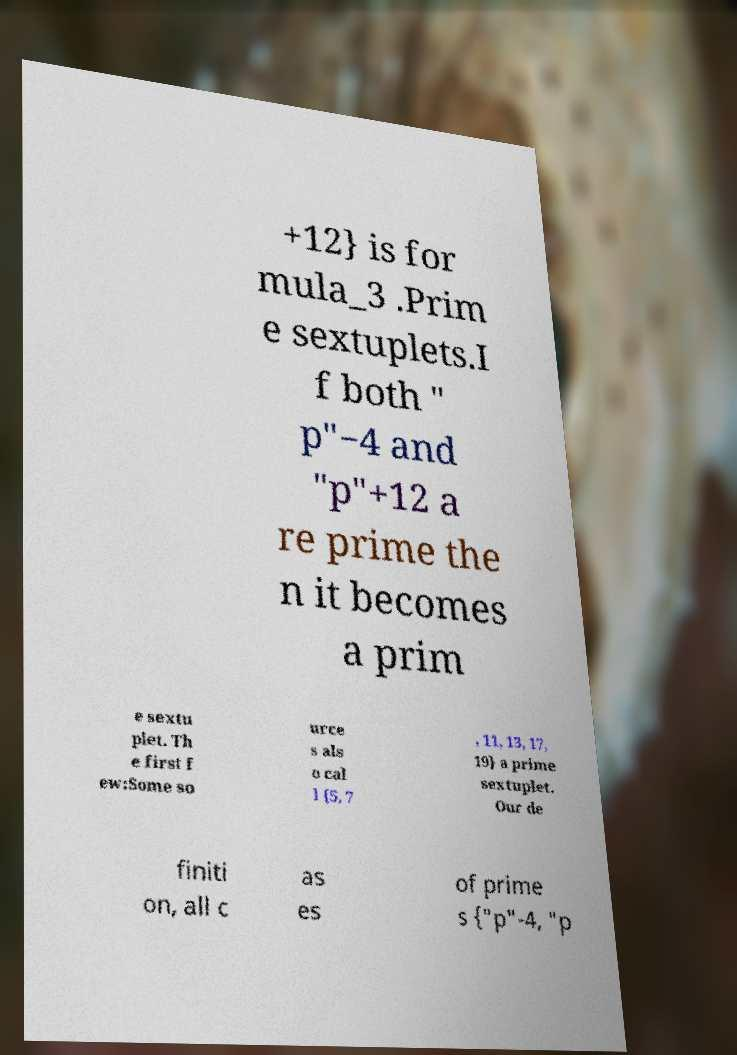Could you extract and type out the text from this image? +12} is for mula_3 .Prim e sextuplets.I f both " p"−4 and "p"+12 a re prime the n it becomes a prim e sextu plet. Th e first f ew:Some so urce s als o cal l {5, 7 , 11, 13, 17, 19} a prime sextuplet. Our de finiti on, all c as es of prime s {"p"-4, "p 